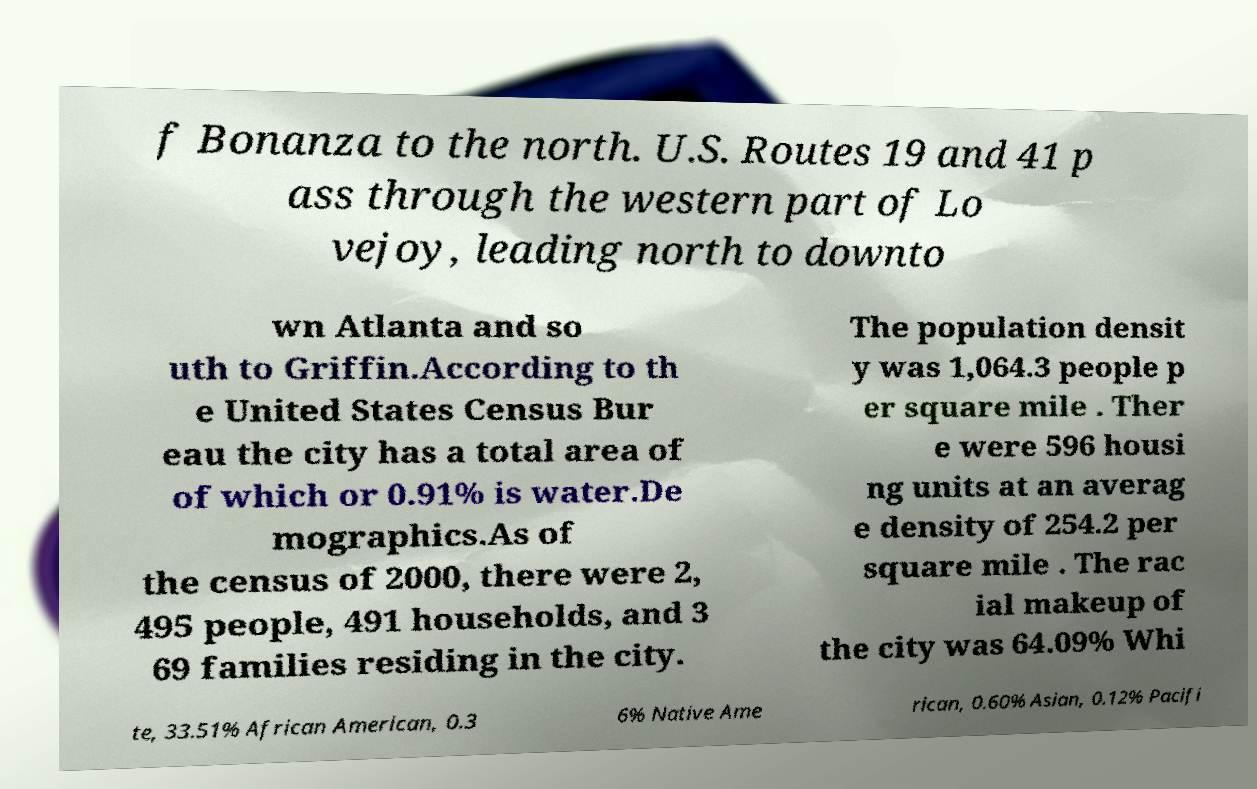Can you read and provide the text displayed in the image?This photo seems to have some interesting text. Can you extract and type it out for me? f Bonanza to the north. U.S. Routes 19 and 41 p ass through the western part of Lo vejoy, leading north to downto wn Atlanta and so uth to Griffin.According to th e United States Census Bur eau the city has a total area of of which or 0.91% is water.De mographics.As of the census of 2000, there were 2, 495 people, 491 households, and 3 69 families residing in the city. The population densit y was 1,064.3 people p er square mile . Ther e were 596 housi ng units at an averag e density of 254.2 per square mile . The rac ial makeup of the city was 64.09% Whi te, 33.51% African American, 0.3 6% Native Ame rican, 0.60% Asian, 0.12% Pacifi 